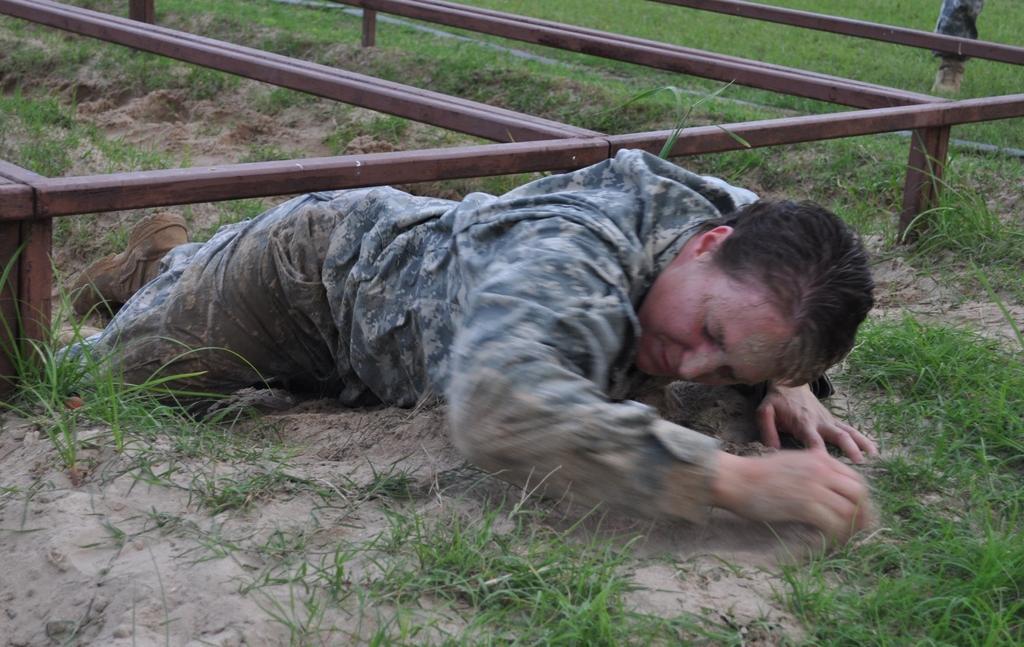How would you summarize this image in a sentence or two? In this image we can see a person. He is wearing uniform. At the bottom there is grass and we can see sand. In the background there are rods. 